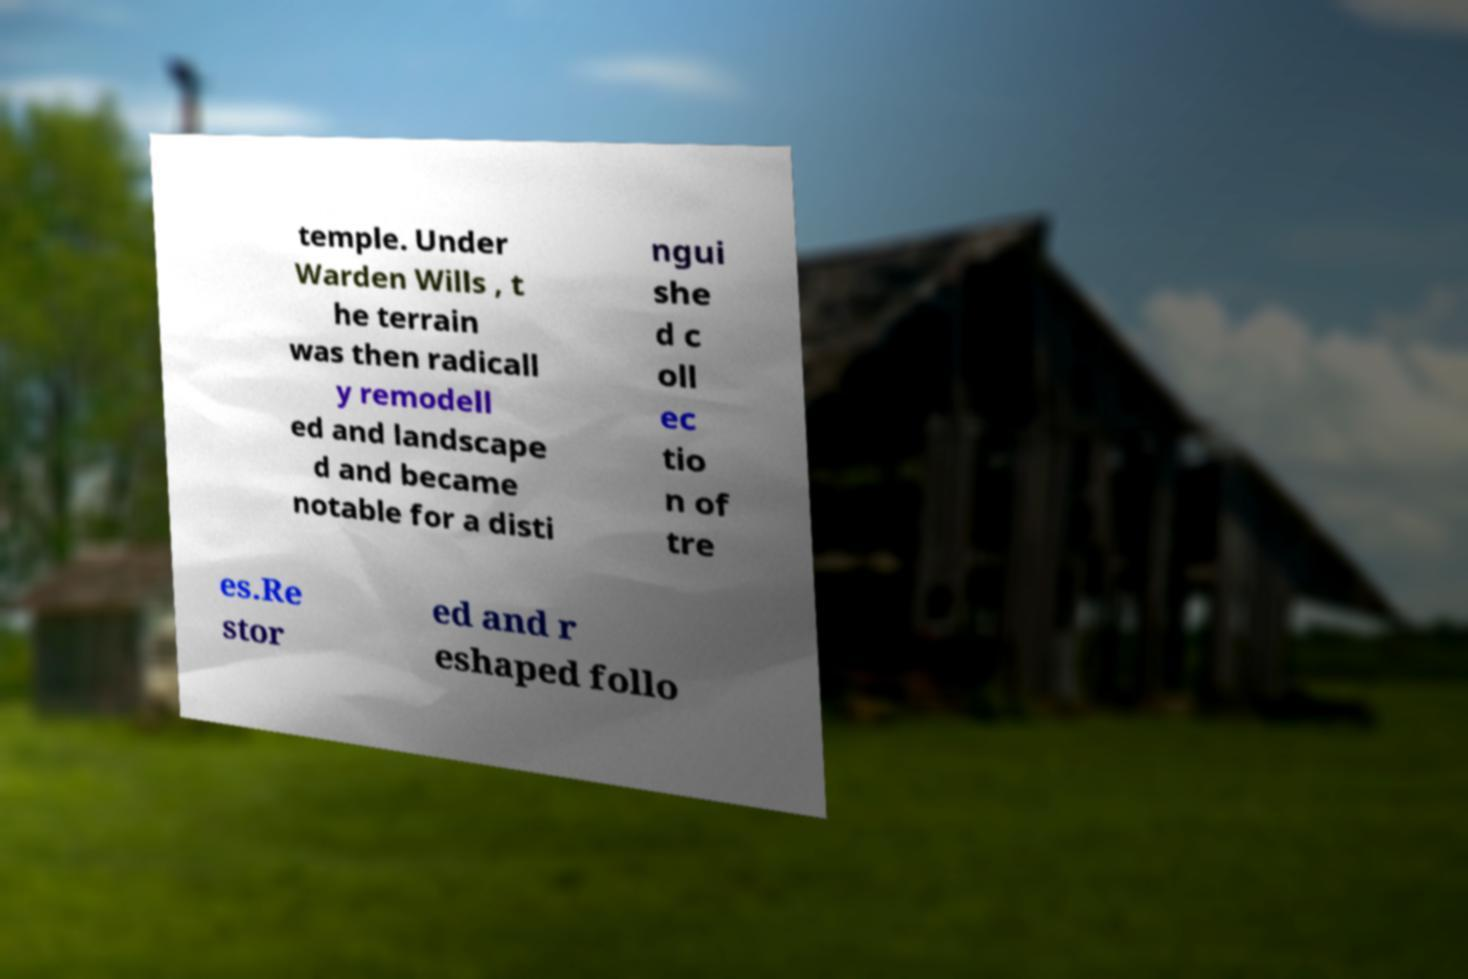Could you assist in decoding the text presented in this image and type it out clearly? temple. Under Warden Wills , t he terrain was then radicall y remodell ed and landscape d and became notable for a disti ngui she d c oll ec tio n of tre es.Re stor ed and r eshaped follo 